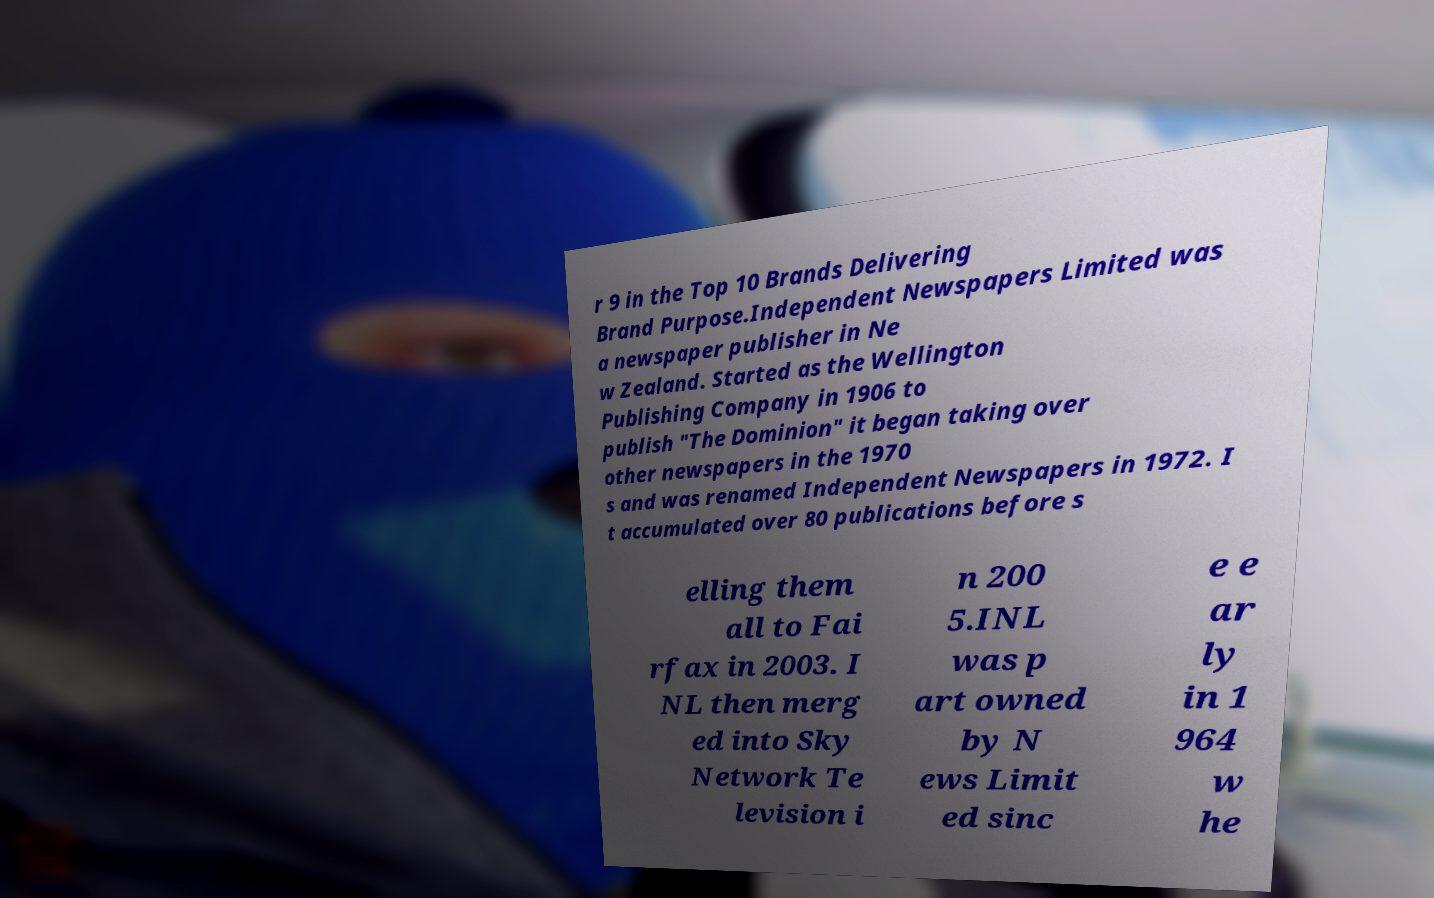What messages or text are displayed in this image? I need them in a readable, typed format. r 9 in the Top 10 Brands Delivering Brand Purpose.Independent Newspapers Limited was a newspaper publisher in Ne w Zealand. Started as the Wellington Publishing Company in 1906 to publish "The Dominion" it began taking over other newspapers in the 1970 s and was renamed Independent Newspapers in 1972. I t accumulated over 80 publications before s elling them all to Fai rfax in 2003. I NL then merg ed into Sky Network Te levision i n 200 5.INL was p art owned by N ews Limit ed sinc e e ar ly in 1 964 w he 